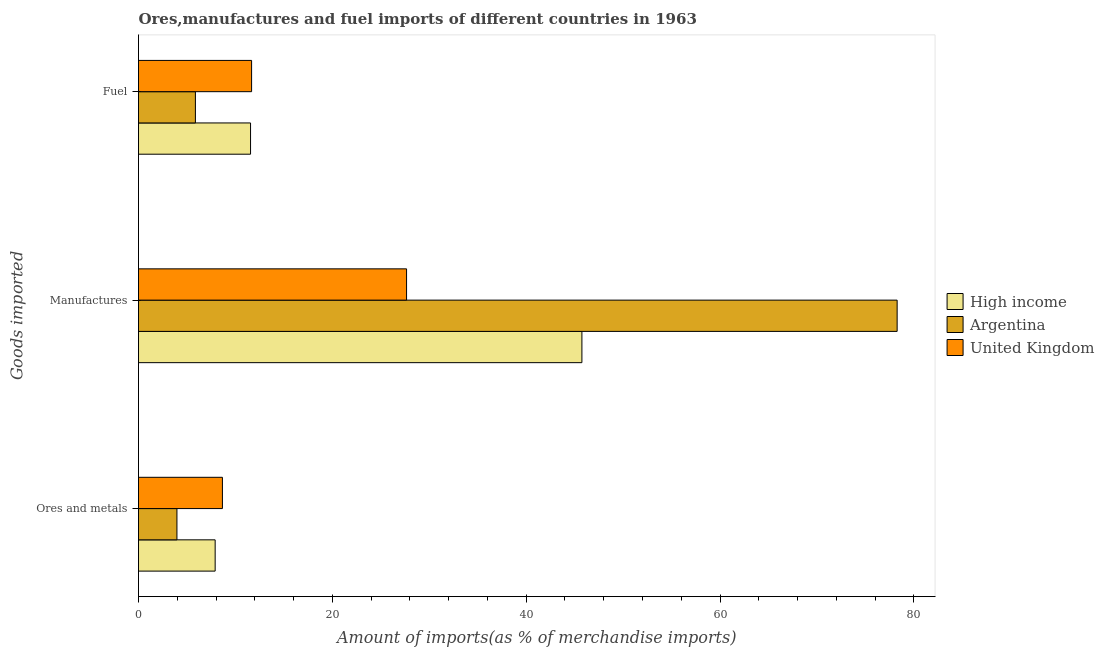How many different coloured bars are there?
Offer a very short reply. 3. How many groups of bars are there?
Offer a terse response. 3. How many bars are there on the 3rd tick from the bottom?
Offer a terse response. 3. What is the label of the 2nd group of bars from the top?
Give a very brief answer. Manufactures. What is the percentage of manufactures imports in United Kingdom?
Your answer should be very brief. 27.66. Across all countries, what is the maximum percentage of manufactures imports?
Your answer should be very brief. 78.27. Across all countries, what is the minimum percentage of ores and metals imports?
Provide a succinct answer. 3.96. What is the total percentage of ores and metals imports in the graph?
Give a very brief answer. 20.53. What is the difference between the percentage of ores and metals imports in High income and that in United Kingdom?
Offer a very short reply. -0.75. What is the difference between the percentage of fuel imports in High income and the percentage of manufactures imports in Argentina?
Ensure brevity in your answer.  -66.71. What is the average percentage of fuel imports per country?
Provide a short and direct response. 9.7. What is the difference between the percentage of fuel imports and percentage of manufactures imports in United Kingdom?
Offer a terse response. -15.99. In how many countries, is the percentage of manufactures imports greater than 16 %?
Your response must be concise. 3. What is the ratio of the percentage of manufactures imports in United Kingdom to that in Argentina?
Provide a short and direct response. 0.35. Is the difference between the percentage of fuel imports in High income and Argentina greater than the difference between the percentage of ores and metals imports in High income and Argentina?
Ensure brevity in your answer.  Yes. What is the difference between the highest and the second highest percentage of ores and metals imports?
Your answer should be compact. 0.75. What is the difference between the highest and the lowest percentage of manufactures imports?
Ensure brevity in your answer.  50.61. In how many countries, is the percentage of ores and metals imports greater than the average percentage of ores and metals imports taken over all countries?
Provide a succinct answer. 2. How many bars are there?
Provide a short and direct response. 9. Are all the bars in the graph horizontal?
Provide a short and direct response. Yes. How many countries are there in the graph?
Your answer should be compact. 3. What is the difference between two consecutive major ticks on the X-axis?
Provide a succinct answer. 20. Are the values on the major ticks of X-axis written in scientific E-notation?
Offer a very short reply. No. Does the graph contain grids?
Ensure brevity in your answer.  No. How many legend labels are there?
Make the answer very short. 3. What is the title of the graph?
Ensure brevity in your answer.  Ores,manufactures and fuel imports of different countries in 1963. What is the label or title of the X-axis?
Provide a short and direct response. Amount of imports(as % of merchandise imports). What is the label or title of the Y-axis?
Give a very brief answer. Goods imported. What is the Amount of imports(as % of merchandise imports) of High income in Ores and metals?
Your answer should be compact. 7.91. What is the Amount of imports(as % of merchandise imports) of Argentina in Ores and metals?
Give a very brief answer. 3.96. What is the Amount of imports(as % of merchandise imports) of United Kingdom in Ores and metals?
Your answer should be compact. 8.66. What is the Amount of imports(as % of merchandise imports) of High income in Manufactures?
Keep it short and to the point. 45.75. What is the Amount of imports(as % of merchandise imports) of Argentina in Manufactures?
Your answer should be compact. 78.27. What is the Amount of imports(as % of merchandise imports) of United Kingdom in Manufactures?
Keep it short and to the point. 27.66. What is the Amount of imports(as % of merchandise imports) in High income in Fuel?
Offer a very short reply. 11.56. What is the Amount of imports(as % of merchandise imports) in Argentina in Fuel?
Give a very brief answer. 5.87. What is the Amount of imports(as % of merchandise imports) of United Kingdom in Fuel?
Your response must be concise. 11.67. Across all Goods imported, what is the maximum Amount of imports(as % of merchandise imports) of High income?
Provide a short and direct response. 45.75. Across all Goods imported, what is the maximum Amount of imports(as % of merchandise imports) of Argentina?
Offer a very short reply. 78.27. Across all Goods imported, what is the maximum Amount of imports(as % of merchandise imports) of United Kingdom?
Your answer should be compact. 27.66. Across all Goods imported, what is the minimum Amount of imports(as % of merchandise imports) of High income?
Your answer should be very brief. 7.91. Across all Goods imported, what is the minimum Amount of imports(as % of merchandise imports) in Argentina?
Your answer should be very brief. 3.96. Across all Goods imported, what is the minimum Amount of imports(as % of merchandise imports) of United Kingdom?
Provide a succinct answer. 8.66. What is the total Amount of imports(as % of merchandise imports) of High income in the graph?
Provide a succinct answer. 65.22. What is the total Amount of imports(as % of merchandise imports) in Argentina in the graph?
Keep it short and to the point. 88.1. What is the total Amount of imports(as % of merchandise imports) in United Kingdom in the graph?
Make the answer very short. 47.98. What is the difference between the Amount of imports(as % of merchandise imports) in High income in Ores and metals and that in Manufactures?
Keep it short and to the point. -37.84. What is the difference between the Amount of imports(as % of merchandise imports) of Argentina in Ores and metals and that in Manufactures?
Your response must be concise. -74.31. What is the difference between the Amount of imports(as % of merchandise imports) in United Kingdom in Ores and metals and that in Manufactures?
Offer a very short reply. -19. What is the difference between the Amount of imports(as % of merchandise imports) of High income in Ores and metals and that in Fuel?
Give a very brief answer. -3.65. What is the difference between the Amount of imports(as % of merchandise imports) of Argentina in Ores and metals and that in Fuel?
Provide a succinct answer. -1.91. What is the difference between the Amount of imports(as % of merchandise imports) in United Kingdom in Ores and metals and that in Fuel?
Your answer should be very brief. -3.01. What is the difference between the Amount of imports(as % of merchandise imports) of High income in Manufactures and that in Fuel?
Keep it short and to the point. 34.19. What is the difference between the Amount of imports(as % of merchandise imports) of Argentina in Manufactures and that in Fuel?
Give a very brief answer. 72.4. What is the difference between the Amount of imports(as % of merchandise imports) of United Kingdom in Manufactures and that in Fuel?
Provide a short and direct response. 15.99. What is the difference between the Amount of imports(as % of merchandise imports) of High income in Ores and metals and the Amount of imports(as % of merchandise imports) of Argentina in Manufactures?
Provide a succinct answer. -70.36. What is the difference between the Amount of imports(as % of merchandise imports) in High income in Ores and metals and the Amount of imports(as % of merchandise imports) in United Kingdom in Manufactures?
Your answer should be very brief. -19.75. What is the difference between the Amount of imports(as % of merchandise imports) in Argentina in Ores and metals and the Amount of imports(as % of merchandise imports) in United Kingdom in Manufactures?
Provide a succinct answer. -23.69. What is the difference between the Amount of imports(as % of merchandise imports) of High income in Ores and metals and the Amount of imports(as % of merchandise imports) of Argentina in Fuel?
Offer a very short reply. 2.04. What is the difference between the Amount of imports(as % of merchandise imports) of High income in Ores and metals and the Amount of imports(as % of merchandise imports) of United Kingdom in Fuel?
Offer a very short reply. -3.76. What is the difference between the Amount of imports(as % of merchandise imports) of Argentina in Ores and metals and the Amount of imports(as % of merchandise imports) of United Kingdom in Fuel?
Ensure brevity in your answer.  -7.7. What is the difference between the Amount of imports(as % of merchandise imports) of High income in Manufactures and the Amount of imports(as % of merchandise imports) of Argentina in Fuel?
Keep it short and to the point. 39.88. What is the difference between the Amount of imports(as % of merchandise imports) of High income in Manufactures and the Amount of imports(as % of merchandise imports) of United Kingdom in Fuel?
Provide a succinct answer. 34.08. What is the difference between the Amount of imports(as % of merchandise imports) in Argentina in Manufactures and the Amount of imports(as % of merchandise imports) in United Kingdom in Fuel?
Offer a terse response. 66.6. What is the average Amount of imports(as % of merchandise imports) in High income per Goods imported?
Make the answer very short. 21.74. What is the average Amount of imports(as % of merchandise imports) of Argentina per Goods imported?
Ensure brevity in your answer.  29.37. What is the average Amount of imports(as % of merchandise imports) in United Kingdom per Goods imported?
Keep it short and to the point. 15.99. What is the difference between the Amount of imports(as % of merchandise imports) in High income and Amount of imports(as % of merchandise imports) in Argentina in Ores and metals?
Ensure brevity in your answer.  3.94. What is the difference between the Amount of imports(as % of merchandise imports) of High income and Amount of imports(as % of merchandise imports) of United Kingdom in Ores and metals?
Provide a succinct answer. -0.75. What is the difference between the Amount of imports(as % of merchandise imports) in Argentina and Amount of imports(as % of merchandise imports) in United Kingdom in Ores and metals?
Offer a very short reply. -4.69. What is the difference between the Amount of imports(as % of merchandise imports) of High income and Amount of imports(as % of merchandise imports) of Argentina in Manufactures?
Offer a very short reply. -32.52. What is the difference between the Amount of imports(as % of merchandise imports) of High income and Amount of imports(as % of merchandise imports) of United Kingdom in Manufactures?
Offer a very short reply. 18.09. What is the difference between the Amount of imports(as % of merchandise imports) of Argentina and Amount of imports(as % of merchandise imports) of United Kingdom in Manufactures?
Offer a terse response. 50.61. What is the difference between the Amount of imports(as % of merchandise imports) in High income and Amount of imports(as % of merchandise imports) in Argentina in Fuel?
Your answer should be very brief. 5.69. What is the difference between the Amount of imports(as % of merchandise imports) in High income and Amount of imports(as % of merchandise imports) in United Kingdom in Fuel?
Keep it short and to the point. -0.11. What is the difference between the Amount of imports(as % of merchandise imports) in Argentina and Amount of imports(as % of merchandise imports) in United Kingdom in Fuel?
Offer a very short reply. -5.8. What is the ratio of the Amount of imports(as % of merchandise imports) of High income in Ores and metals to that in Manufactures?
Keep it short and to the point. 0.17. What is the ratio of the Amount of imports(as % of merchandise imports) in Argentina in Ores and metals to that in Manufactures?
Offer a very short reply. 0.05. What is the ratio of the Amount of imports(as % of merchandise imports) of United Kingdom in Ores and metals to that in Manufactures?
Keep it short and to the point. 0.31. What is the ratio of the Amount of imports(as % of merchandise imports) in High income in Ores and metals to that in Fuel?
Offer a very short reply. 0.68. What is the ratio of the Amount of imports(as % of merchandise imports) in Argentina in Ores and metals to that in Fuel?
Offer a terse response. 0.68. What is the ratio of the Amount of imports(as % of merchandise imports) in United Kingdom in Ores and metals to that in Fuel?
Provide a succinct answer. 0.74. What is the ratio of the Amount of imports(as % of merchandise imports) in High income in Manufactures to that in Fuel?
Make the answer very short. 3.96. What is the ratio of the Amount of imports(as % of merchandise imports) in Argentina in Manufactures to that in Fuel?
Offer a terse response. 13.33. What is the ratio of the Amount of imports(as % of merchandise imports) in United Kingdom in Manufactures to that in Fuel?
Your answer should be compact. 2.37. What is the difference between the highest and the second highest Amount of imports(as % of merchandise imports) in High income?
Your answer should be very brief. 34.19. What is the difference between the highest and the second highest Amount of imports(as % of merchandise imports) of Argentina?
Keep it short and to the point. 72.4. What is the difference between the highest and the second highest Amount of imports(as % of merchandise imports) of United Kingdom?
Provide a short and direct response. 15.99. What is the difference between the highest and the lowest Amount of imports(as % of merchandise imports) in High income?
Ensure brevity in your answer.  37.84. What is the difference between the highest and the lowest Amount of imports(as % of merchandise imports) in Argentina?
Make the answer very short. 74.31. What is the difference between the highest and the lowest Amount of imports(as % of merchandise imports) of United Kingdom?
Your answer should be very brief. 19. 